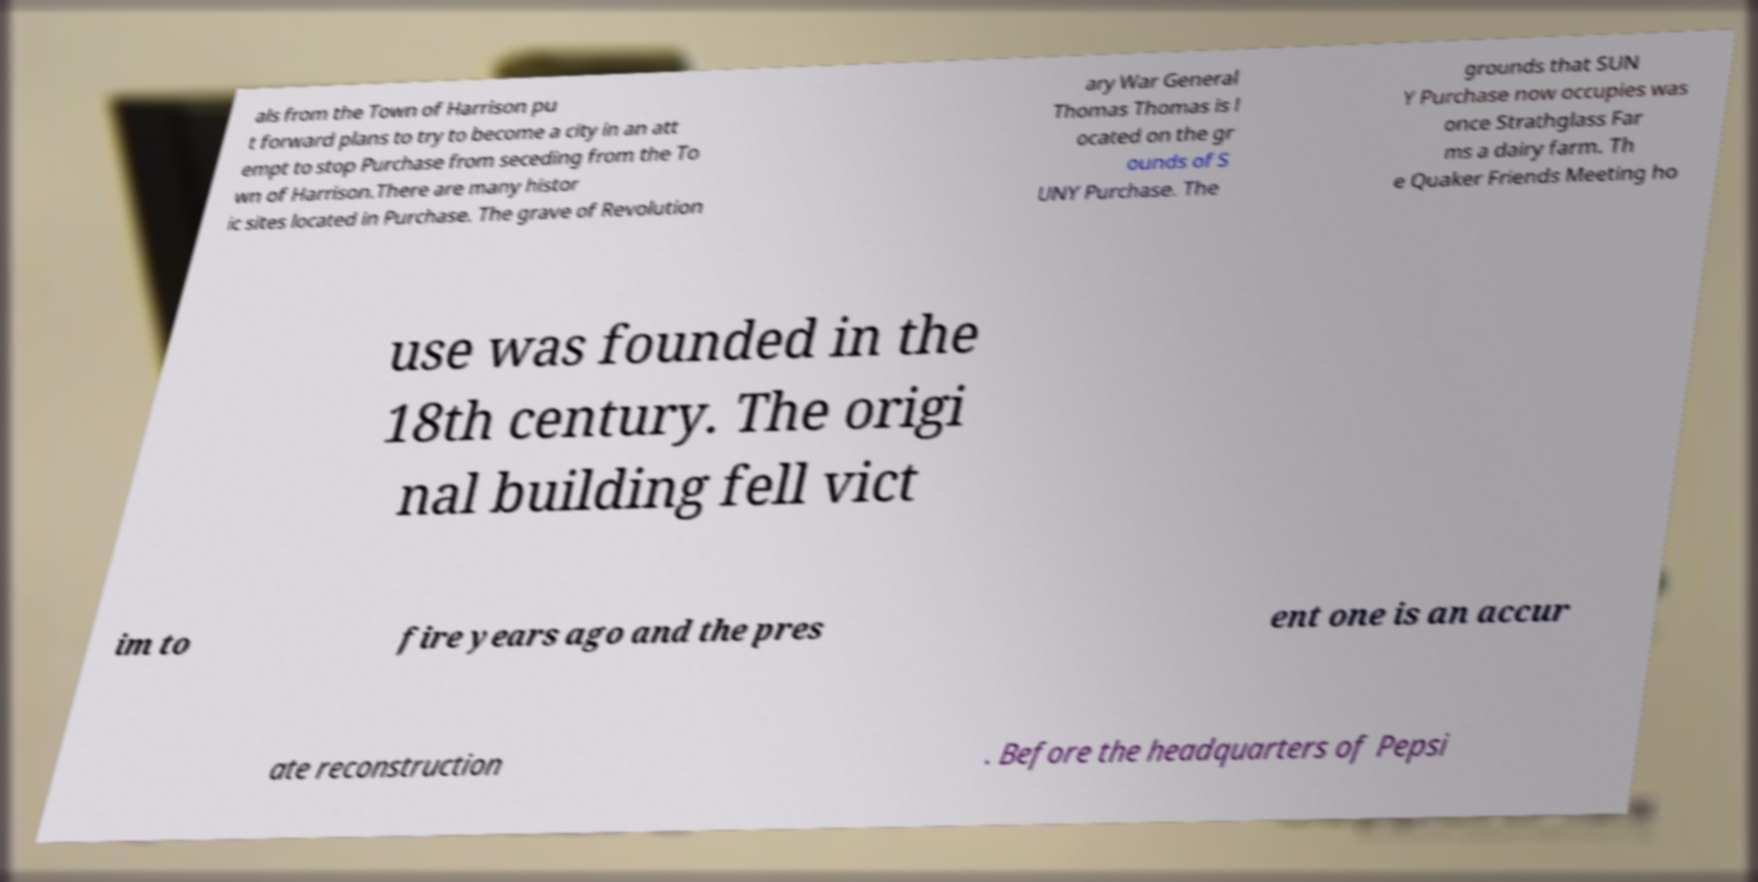What messages or text are displayed in this image? I need them in a readable, typed format. als from the Town of Harrison pu t forward plans to try to become a city in an att empt to stop Purchase from seceding from the To wn of Harrison.There are many histor ic sites located in Purchase. The grave of Revolution ary War General Thomas Thomas is l ocated on the gr ounds of S UNY Purchase. The grounds that SUN Y Purchase now occupies was once Strathglass Far ms a dairy farm. Th e Quaker Friends Meeting ho use was founded in the 18th century. The origi nal building fell vict im to fire years ago and the pres ent one is an accur ate reconstruction . Before the headquarters of Pepsi 